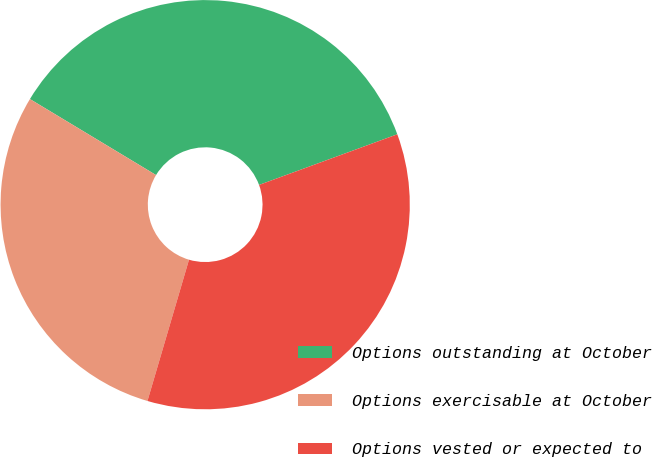Convert chart. <chart><loc_0><loc_0><loc_500><loc_500><pie_chart><fcel>Options outstanding at October<fcel>Options exercisable at October<fcel>Options vested or expected to<nl><fcel>35.78%<fcel>29.08%<fcel>35.14%<nl></chart> 